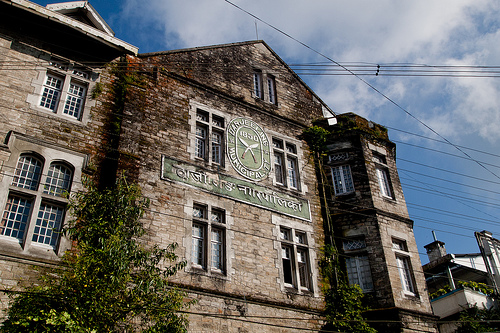<image>
Can you confirm if the power lines is behind the building? No. The power lines is not behind the building. From this viewpoint, the power lines appears to be positioned elsewhere in the scene. 